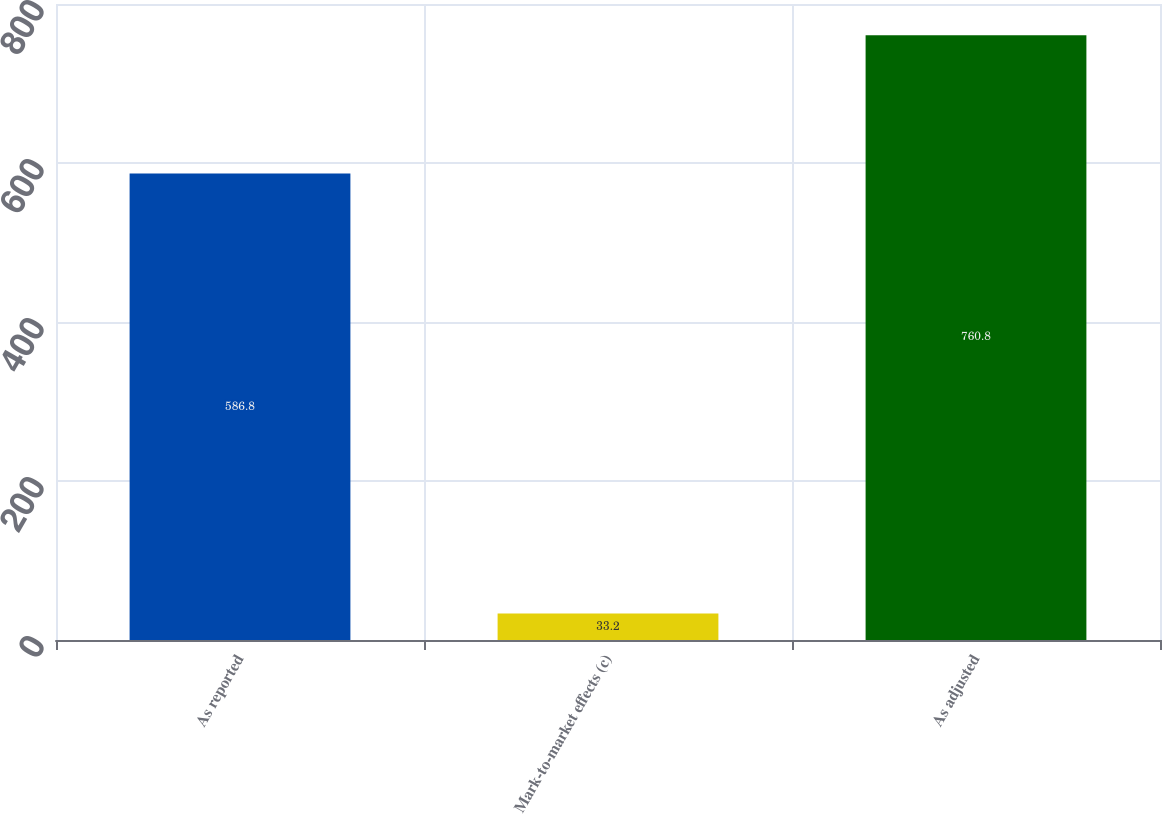<chart> <loc_0><loc_0><loc_500><loc_500><bar_chart><fcel>As reported<fcel>Mark-to-market effects (c)<fcel>As adjusted<nl><fcel>586.8<fcel>33.2<fcel>760.8<nl></chart> 